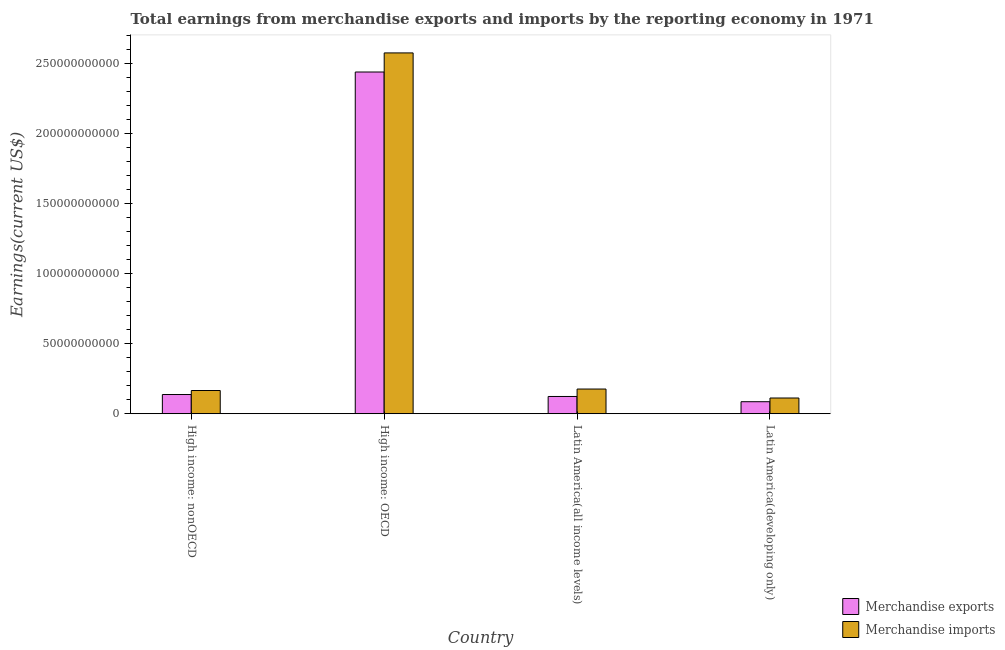How many different coloured bars are there?
Your response must be concise. 2. How many groups of bars are there?
Offer a very short reply. 4. Are the number of bars per tick equal to the number of legend labels?
Keep it short and to the point. Yes. Are the number of bars on each tick of the X-axis equal?
Your answer should be very brief. Yes. How many bars are there on the 2nd tick from the right?
Your response must be concise. 2. What is the label of the 4th group of bars from the left?
Give a very brief answer. Latin America(developing only). What is the earnings from merchandise exports in Latin America(developing only)?
Your answer should be very brief. 8.58e+09. Across all countries, what is the maximum earnings from merchandise exports?
Your response must be concise. 2.44e+11. Across all countries, what is the minimum earnings from merchandise imports?
Your answer should be compact. 1.12e+1. In which country was the earnings from merchandise exports maximum?
Provide a succinct answer. High income: OECD. In which country was the earnings from merchandise exports minimum?
Provide a succinct answer. Latin America(developing only). What is the total earnings from merchandise imports in the graph?
Offer a terse response. 3.03e+11. What is the difference between the earnings from merchandise imports in High income: nonOECD and that in Latin America(developing only)?
Ensure brevity in your answer.  5.35e+09. What is the difference between the earnings from merchandise imports in Latin America(developing only) and the earnings from merchandise exports in High income: nonOECD?
Provide a short and direct response. -2.49e+09. What is the average earnings from merchandise exports per country?
Ensure brevity in your answer.  6.96e+1. What is the difference between the earnings from merchandise imports and earnings from merchandise exports in High income: nonOECD?
Your answer should be very brief. 2.86e+09. In how many countries, is the earnings from merchandise exports greater than 60000000000 US$?
Your answer should be very brief. 1. What is the ratio of the earnings from merchandise imports in High income: nonOECD to that in Latin America(developing only)?
Offer a terse response. 1.48. Is the earnings from merchandise exports in High income: OECD less than that in Latin America(developing only)?
Provide a succinct answer. No. Is the difference between the earnings from merchandise exports in High income: nonOECD and Latin America(all income levels) greater than the difference between the earnings from merchandise imports in High income: nonOECD and Latin America(all income levels)?
Make the answer very short. Yes. What is the difference between the highest and the second highest earnings from merchandise imports?
Give a very brief answer. 2.40e+11. What is the difference between the highest and the lowest earnings from merchandise imports?
Ensure brevity in your answer.  2.46e+11. What does the 2nd bar from the left in Latin America(all income levels) represents?
Make the answer very short. Merchandise imports. What does the 1st bar from the right in High income: OECD represents?
Your answer should be very brief. Merchandise imports. Are all the bars in the graph horizontal?
Provide a succinct answer. No. Are the values on the major ticks of Y-axis written in scientific E-notation?
Provide a short and direct response. No. Does the graph contain any zero values?
Provide a succinct answer. No. Does the graph contain grids?
Provide a succinct answer. No. How many legend labels are there?
Provide a succinct answer. 2. What is the title of the graph?
Your answer should be compact. Total earnings from merchandise exports and imports by the reporting economy in 1971. What is the label or title of the Y-axis?
Provide a succinct answer. Earnings(current US$). What is the Earnings(current US$) in Merchandise exports in High income: nonOECD?
Your answer should be very brief. 1.37e+1. What is the Earnings(current US$) in Merchandise imports in High income: nonOECD?
Keep it short and to the point. 1.66e+1. What is the Earnings(current US$) of Merchandise exports in High income: OECD?
Your answer should be very brief. 2.44e+11. What is the Earnings(current US$) of Merchandise imports in High income: OECD?
Provide a succinct answer. 2.57e+11. What is the Earnings(current US$) of Merchandise exports in Latin America(all income levels)?
Your response must be concise. 1.23e+1. What is the Earnings(current US$) in Merchandise imports in Latin America(all income levels)?
Keep it short and to the point. 1.76e+1. What is the Earnings(current US$) in Merchandise exports in Latin America(developing only)?
Your answer should be compact. 8.58e+09. What is the Earnings(current US$) in Merchandise imports in Latin America(developing only)?
Your answer should be very brief. 1.12e+1. Across all countries, what is the maximum Earnings(current US$) in Merchandise exports?
Offer a very short reply. 2.44e+11. Across all countries, what is the maximum Earnings(current US$) in Merchandise imports?
Provide a short and direct response. 2.57e+11. Across all countries, what is the minimum Earnings(current US$) in Merchandise exports?
Offer a terse response. 8.58e+09. Across all countries, what is the minimum Earnings(current US$) of Merchandise imports?
Your response must be concise. 1.12e+1. What is the total Earnings(current US$) of Merchandise exports in the graph?
Your answer should be very brief. 2.78e+11. What is the total Earnings(current US$) of Merchandise imports in the graph?
Offer a terse response. 3.03e+11. What is the difference between the Earnings(current US$) in Merchandise exports in High income: nonOECD and that in High income: OECD?
Make the answer very short. -2.30e+11. What is the difference between the Earnings(current US$) in Merchandise imports in High income: nonOECD and that in High income: OECD?
Keep it short and to the point. -2.41e+11. What is the difference between the Earnings(current US$) of Merchandise exports in High income: nonOECD and that in Latin America(all income levels)?
Give a very brief answer. 1.39e+09. What is the difference between the Earnings(current US$) in Merchandise imports in High income: nonOECD and that in Latin America(all income levels)?
Your answer should be very brief. -1.04e+09. What is the difference between the Earnings(current US$) of Merchandise exports in High income: nonOECD and that in Latin America(developing only)?
Offer a very short reply. 5.13e+09. What is the difference between the Earnings(current US$) of Merchandise imports in High income: nonOECD and that in Latin America(developing only)?
Offer a terse response. 5.35e+09. What is the difference between the Earnings(current US$) in Merchandise exports in High income: OECD and that in Latin America(all income levels)?
Provide a succinct answer. 2.31e+11. What is the difference between the Earnings(current US$) of Merchandise imports in High income: OECD and that in Latin America(all income levels)?
Keep it short and to the point. 2.40e+11. What is the difference between the Earnings(current US$) in Merchandise exports in High income: OECD and that in Latin America(developing only)?
Your response must be concise. 2.35e+11. What is the difference between the Earnings(current US$) in Merchandise imports in High income: OECD and that in Latin America(developing only)?
Provide a short and direct response. 2.46e+11. What is the difference between the Earnings(current US$) of Merchandise exports in Latin America(all income levels) and that in Latin America(developing only)?
Your response must be concise. 3.74e+09. What is the difference between the Earnings(current US$) of Merchandise imports in Latin America(all income levels) and that in Latin America(developing only)?
Ensure brevity in your answer.  6.39e+09. What is the difference between the Earnings(current US$) in Merchandise exports in High income: nonOECD and the Earnings(current US$) in Merchandise imports in High income: OECD?
Provide a short and direct response. -2.44e+11. What is the difference between the Earnings(current US$) in Merchandise exports in High income: nonOECD and the Earnings(current US$) in Merchandise imports in Latin America(all income levels)?
Offer a terse response. -3.91e+09. What is the difference between the Earnings(current US$) of Merchandise exports in High income: nonOECD and the Earnings(current US$) of Merchandise imports in Latin America(developing only)?
Your answer should be compact. 2.49e+09. What is the difference between the Earnings(current US$) of Merchandise exports in High income: OECD and the Earnings(current US$) of Merchandise imports in Latin America(all income levels)?
Make the answer very short. 2.26e+11. What is the difference between the Earnings(current US$) in Merchandise exports in High income: OECD and the Earnings(current US$) in Merchandise imports in Latin America(developing only)?
Make the answer very short. 2.33e+11. What is the difference between the Earnings(current US$) of Merchandise exports in Latin America(all income levels) and the Earnings(current US$) of Merchandise imports in Latin America(developing only)?
Give a very brief answer. 1.09e+09. What is the average Earnings(current US$) in Merchandise exports per country?
Provide a short and direct response. 6.96e+1. What is the average Earnings(current US$) in Merchandise imports per country?
Offer a terse response. 7.57e+1. What is the difference between the Earnings(current US$) of Merchandise exports and Earnings(current US$) of Merchandise imports in High income: nonOECD?
Provide a succinct answer. -2.86e+09. What is the difference between the Earnings(current US$) of Merchandise exports and Earnings(current US$) of Merchandise imports in High income: OECD?
Offer a very short reply. -1.36e+1. What is the difference between the Earnings(current US$) of Merchandise exports and Earnings(current US$) of Merchandise imports in Latin America(all income levels)?
Keep it short and to the point. -5.30e+09. What is the difference between the Earnings(current US$) in Merchandise exports and Earnings(current US$) in Merchandise imports in Latin America(developing only)?
Provide a short and direct response. -2.64e+09. What is the ratio of the Earnings(current US$) in Merchandise exports in High income: nonOECD to that in High income: OECD?
Make the answer very short. 0.06. What is the ratio of the Earnings(current US$) of Merchandise imports in High income: nonOECD to that in High income: OECD?
Give a very brief answer. 0.06. What is the ratio of the Earnings(current US$) of Merchandise exports in High income: nonOECD to that in Latin America(all income levels)?
Keep it short and to the point. 1.11. What is the ratio of the Earnings(current US$) of Merchandise imports in High income: nonOECD to that in Latin America(all income levels)?
Offer a terse response. 0.94. What is the ratio of the Earnings(current US$) in Merchandise exports in High income: nonOECD to that in Latin America(developing only)?
Provide a succinct answer. 1.6. What is the ratio of the Earnings(current US$) in Merchandise imports in High income: nonOECD to that in Latin America(developing only)?
Keep it short and to the point. 1.48. What is the ratio of the Earnings(current US$) in Merchandise exports in High income: OECD to that in Latin America(all income levels)?
Keep it short and to the point. 19.8. What is the ratio of the Earnings(current US$) of Merchandise imports in High income: OECD to that in Latin America(all income levels)?
Provide a short and direct response. 14.61. What is the ratio of the Earnings(current US$) in Merchandise exports in High income: OECD to that in Latin America(developing only)?
Keep it short and to the point. 28.42. What is the ratio of the Earnings(current US$) in Merchandise imports in High income: OECD to that in Latin America(developing only)?
Your response must be concise. 22.93. What is the ratio of the Earnings(current US$) of Merchandise exports in Latin America(all income levels) to that in Latin America(developing only)?
Make the answer very short. 1.44. What is the ratio of the Earnings(current US$) in Merchandise imports in Latin America(all income levels) to that in Latin America(developing only)?
Your answer should be very brief. 1.57. What is the difference between the highest and the second highest Earnings(current US$) in Merchandise exports?
Make the answer very short. 2.30e+11. What is the difference between the highest and the second highest Earnings(current US$) in Merchandise imports?
Offer a terse response. 2.40e+11. What is the difference between the highest and the lowest Earnings(current US$) of Merchandise exports?
Keep it short and to the point. 2.35e+11. What is the difference between the highest and the lowest Earnings(current US$) of Merchandise imports?
Ensure brevity in your answer.  2.46e+11. 